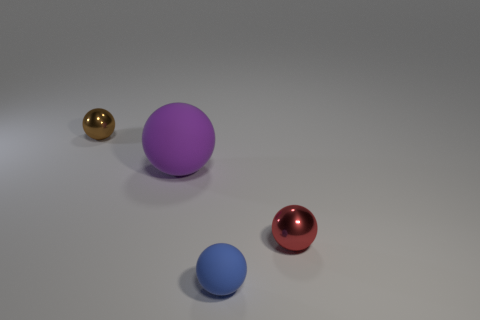Subtract all green spheres. Subtract all yellow cylinders. How many spheres are left? 4 Add 4 large rubber cubes. How many objects exist? 8 Subtract all rubber balls. Subtract all rubber balls. How many objects are left? 0 Add 2 tiny red metallic spheres. How many tiny red metallic spheres are left? 3 Add 4 large spheres. How many large spheres exist? 5 Subtract 0 brown cylinders. How many objects are left? 4 